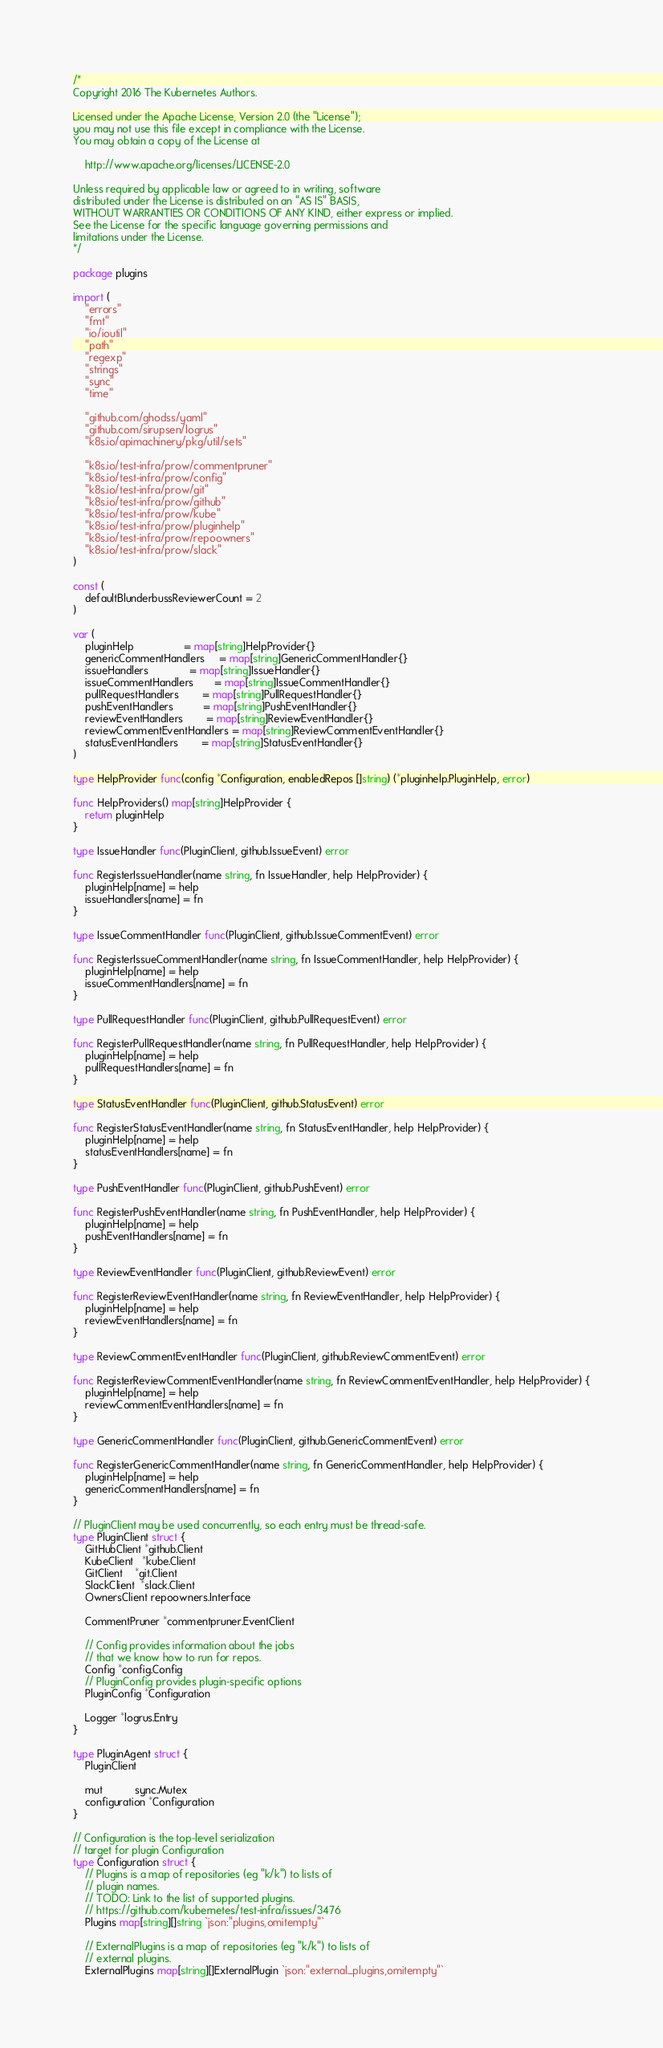Convert code to text. <code><loc_0><loc_0><loc_500><loc_500><_Go_>/*
Copyright 2016 The Kubernetes Authors.

Licensed under the Apache License, Version 2.0 (the "License");
you may not use this file except in compliance with the License.
You may obtain a copy of the License at

    http://www.apache.org/licenses/LICENSE-2.0

Unless required by applicable law or agreed to in writing, software
distributed under the License is distributed on an "AS IS" BASIS,
WITHOUT WARRANTIES OR CONDITIONS OF ANY KIND, either express or implied.
See the License for the specific language governing permissions and
limitations under the License.
*/

package plugins

import (
	"errors"
	"fmt"
	"io/ioutil"
	"path"
	"regexp"
	"strings"
	"sync"
	"time"

	"github.com/ghodss/yaml"
	"github.com/sirupsen/logrus"
	"k8s.io/apimachinery/pkg/util/sets"

	"k8s.io/test-infra/prow/commentpruner"
	"k8s.io/test-infra/prow/config"
	"k8s.io/test-infra/prow/git"
	"k8s.io/test-infra/prow/github"
	"k8s.io/test-infra/prow/kube"
	"k8s.io/test-infra/prow/pluginhelp"
	"k8s.io/test-infra/prow/repoowners"
	"k8s.io/test-infra/prow/slack"
)

const (
	defaultBlunderbussReviewerCount = 2
)

var (
	pluginHelp                 = map[string]HelpProvider{}
	genericCommentHandlers     = map[string]GenericCommentHandler{}
	issueHandlers              = map[string]IssueHandler{}
	issueCommentHandlers       = map[string]IssueCommentHandler{}
	pullRequestHandlers        = map[string]PullRequestHandler{}
	pushEventHandlers          = map[string]PushEventHandler{}
	reviewEventHandlers        = map[string]ReviewEventHandler{}
	reviewCommentEventHandlers = map[string]ReviewCommentEventHandler{}
	statusEventHandlers        = map[string]StatusEventHandler{}
)

type HelpProvider func(config *Configuration, enabledRepos []string) (*pluginhelp.PluginHelp, error)

func HelpProviders() map[string]HelpProvider {
	return pluginHelp
}

type IssueHandler func(PluginClient, github.IssueEvent) error

func RegisterIssueHandler(name string, fn IssueHandler, help HelpProvider) {
	pluginHelp[name] = help
	issueHandlers[name] = fn
}

type IssueCommentHandler func(PluginClient, github.IssueCommentEvent) error

func RegisterIssueCommentHandler(name string, fn IssueCommentHandler, help HelpProvider) {
	pluginHelp[name] = help
	issueCommentHandlers[name] = fn
}

type PullRequestHandler func(PluginClient, github.PullRequestEvent) error

func RegisterPullRequestHandler(name string, fn PullRequestHandler, help HelpProvider) {
	pluginHelp[name] = help
	pullRequestHandlers[name] = fn
}

type StatusEventHandler func(PluginClient, github.StatusEvent) error

func RegisterStatusEventHandler(name string, fn StatusEventHandler, help HelpProvider) {
	pluginHelp[name] = help
	statusEventHandlers[name] = fn
}

type PushEventHandler func(PluginClient, github.PushEvent) error

func RegisterPushEventHandler(name string, fn PushEventHandler, help HelpProvider) {
	pluginHelp[name] = help
	pushEventHandlers[name] = fn
}

type ReviewEventHandler func(PluginClient, github.ReviewEvent) error

func RegisterReviewEventHandler(name string, fn ReviewEventHandler, help HelpProvider) {
	pluginHelp[name] = help
	reviewEventHandlers[name] = fn
}

type ReviewCommentEventHandler func(PluginClient, github.ReviewCommentEvent) error

func RegisterReviewCommentEventHandler(name string, fn ReviewCommentEventHandler, help HelpProvider) {
	pluginHelp[name] = help
	reviewCommentEventHandlers[name] = fn
}

type GenericCommentHandler func(PluginClient, github.GenericCommentEvent) error

func RegisterGenericCommentHandler(name string, fn GenericCommentHandler, help HelpProvider) {
	pluginHelp[name] = help
	genericCommentHandlers[name] = fn
}

// PluginClient may be used concurrently, so each entry must be thread-safe.
type PluginClient struct {
	GitHubClient *github.Client
	KubeClient   *kube.Client
	GitClient    *git.Client
	SlackClient  *slack.Client
	OwnersClient repoowners.Interface

	CommentPruner *commentpruner.EventClient

	// Config provides information about the jobs
	// that we know how to run for repos.
	Config *config.Config
	// PluginConfig provides plugin-specific options
	PluginConfig *Configuration

	Logger *logrus.Entry
}

type PluginAgent struct {
	PluginClient

	mut           sync.Mutex
	configuration *Configuration
}

// Configuration is the top-level serialization
// target for plugin Configuration
type Configuration struct {
	// Plugins is a map of repositories (eg "k/k") to lists of
	// plugin names.
	// TODO: Link to the list of supported plugins.
	// https://github.com/kubernetes/test-infra/issues/3476
	Plugins map[string][]string `json:"plugins,omitempty"`

	// ExternalPlugins is a map of repositories (eg "k/k") to lists of
	// external plugins.
	ExternalPlugins map[string][]ExternalPlugin `json:"external_plugins,omitempty"`
</code> 